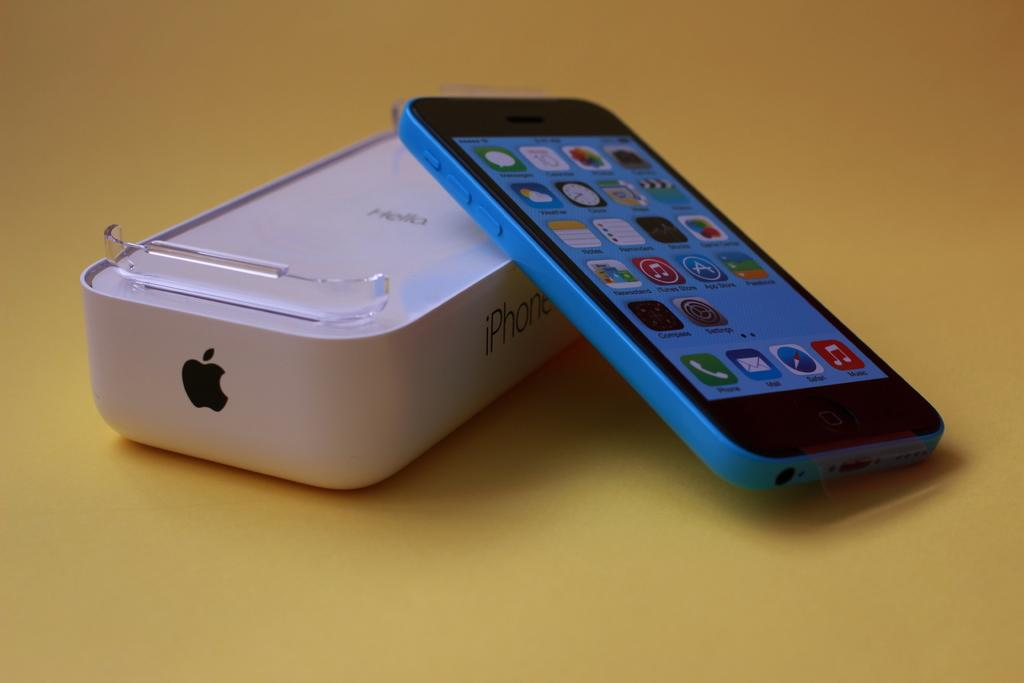<image>
Write a terse but informative summary of the picture. Apple's iPhone is available in a metallic blue color. 